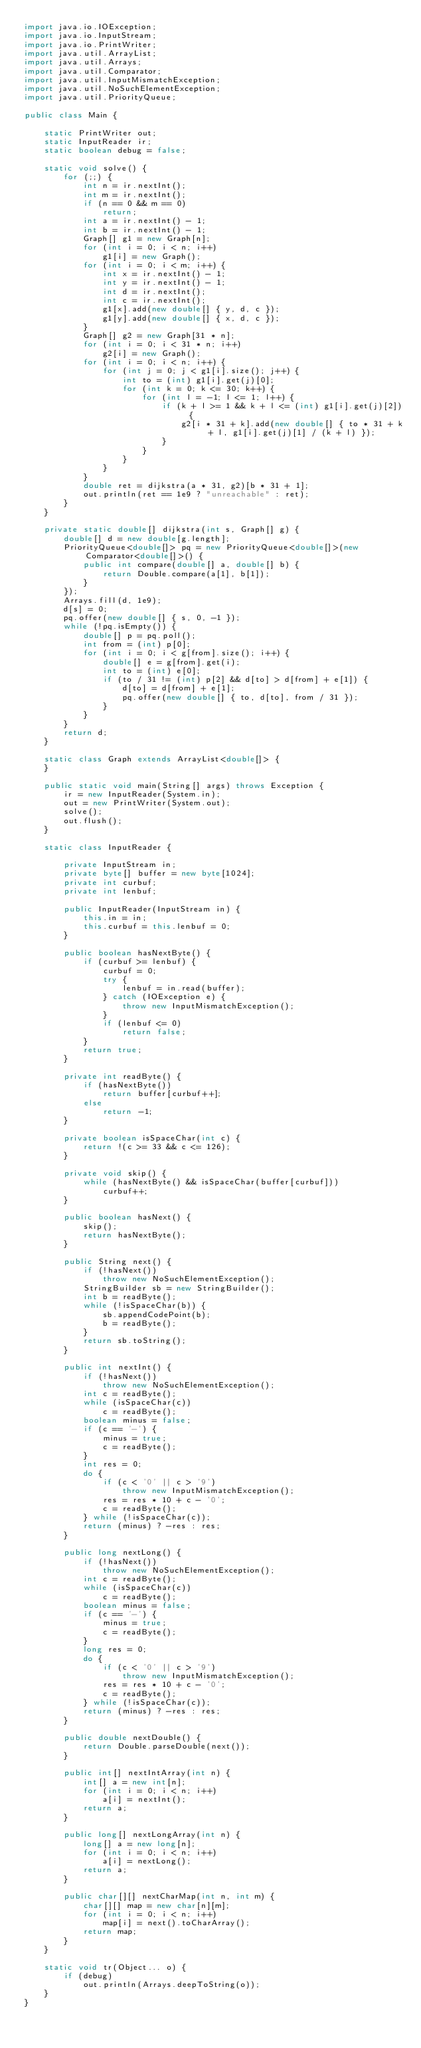<code> <loc_0><loc_0><loc_500><loc_500><_Java_>import java.io.IOException;
import java.io.InputStream;
import java.io.PrintWriter;
import java.util.ArrayList;
import java.util.Arrays;
import java.util.Comparator;
import java.util.InputMismatchException;
import java.util.NoSuchElementException;
import java.util.PriorityQueue;

public class Main {

	static PrintWriter out;
	static InputReader ir;
	static boolean debug = false;

	static void solve() {
		for (;;) {
			int n = ir.nextInt();
			int m = ir.nextInt();
			if (n == 0 && m == 0)
				return;
			int a = ir.nextInt() - 1;
			int b = ir.nextInt() - 1;
			Graph[] g1 = new Graph[n];
			for (int i = 0; i < n; i++)
				g1[i] = new Graph();
			for (int i = 0; i < m; i++) {
				int x = ir.nextInt() - 1;
				int y = ir.nextInt() - 1;
				int d = ir.nextInt();
				int c = ir.nextInt();
				g1[x].add(new double[] { y, d, c });
				g1[y].add(new double[] { x, d, c });
			}
			Graph[] g2 = new Graph[31 * n];
			for (int i = 0; i < 31 * n; i++)
				g2[i] = new Graph();
			for (int i = 0; i < n; i++) {
				for (int j = 0; j < g1[i].size(); j++) {
					int to = (int) g1[i].get(j)[0];
					for (int k = 0; k <= 30; k++) {
						for (int l = -1; l <= 1; l++) {
							if (k + l >= 1 && k + l <= (int) g1[i].get(j)[2]) {
								g2[i * 31 + k].add(new double[] { to * 31 + k + l, g1[i].get(j)[1] / (k + l) });
							}
						}
					}
				}
			}
			double ret = dijkstra(a * 31, g2)[b * 31 + 1];
			out.println(ret == 1e9 ? "unreachable" : ret);
		}
	}

	private static double[] dijkstra(int s, Graph[] g) {
		double[] d = new double[g.length];
		PriorityQueue<double[]> pq = new PriorityQueue<double[]>(new Comparator<double[]>() {
			public int compare(double[] a, double[] b) {
				return Double.compare(a[1], b[1]);
			}
		});
		Arrays.fill(d, 1e9);
		d[s] = 0;
		pq.offer(new double[] { s, 0, -1 });
		while (!pq.isEmpty()) {
			double[] p = pq.poll();
			int from = (int) p[0];
			for (int i = 0; i < g[from].size(); i++) {
				double[] e = g[from].get(i);
				int to = (int) e[0];
				if (to / 31 != (int) p[2] && d[to] > d[from] + e[1]) {
					d[to] = d[from] + e[1];
					pq.offer(new double[] { to, d[to], from / 31 });
				}
			}
		}
		return d;
	}

	static class Graph extends ArrayList<double[]> {
	}

	public static void main(String[] args) throws Exception {
		ir = new InputReader(System.in);
		out = new PrintWriter(System.out);
		solve();
		out.flush();
	}

	static class InputReader {

		private InputStream in;
		private byte[] buffer = new byte[1024];
		private int curbuf;
		private int lenbuf;

		public InputReader(InputStream in) {
			this.in = in;
			this.curbuf = this.lenbuf = 0;
		}

		public boolean hasNextByte() {
			if (curbuf >= lenbuf) {
				curbuf = 0;
				try {
					lenbuf = in.read(buffer);
				} catch (IOException e) {
					throw new InputMismatchException();
				}
				if (lenbuf <= 0)
					return false;
			}
			return true;
		}

		private int readByte() {
			if (hasNextByte())
				return buffer[curbuf++];
			else
				return -1;
		}

		private boolean isSpaceChar(int c) {
			return !(c >= 33 && c <= 126);
		}

		private void skip() {
			while (hasNextByte() && isSpaceChar(buffer[curbuf]))
				curbuf++;
		}

		public boolean hasNext() {
			skip();
			return hasNextByte();
		}

		public String next() {
			if (!hasNext())
				throw new NoSuchElementException();
			StringBuilder sb = new StringBuilder();
			int b = readByte();
			while (!isSpaceChar(b)) {
				sb.appendCodePoint(b);
				b = readByte();
			}
			return sb.toString();
		}

		public int nextInt() {
			if (!hasNext())
				throw new NoSuchElementException();
			int c = readByte();
			while (isSpaceChar(c))
				c = readByte();
			boolean minus = false;
			if (c == '-') {
				minus = true;
				c = readByte();
			}
			int res = 0;
			do {
				if (c < '0' || c > '9')
					throw new InputMismatchException();
				res = res * 10 + c - '0';
				c = readByte();
			} while (!isSpaceChar(c));
			return (minus) ? -res : res;
		}

		public long nextLong() {
			if (!hasNext())
				throw new NoSuchElementException();
			int c = readByte();
			while (isSpaceChar(c))
				c = readByte();
			boolean minus = false;
			if (c == '-') {
				minus = true;
				c = readByte();
			}
			long res = 0;
			do {
				if (c < '0' || c > '9')
					throw new InputMismatchException();
				res = res * 10 + c - '0';
				c = readByte();
			} while (!isSpaceChar(c));
			return (minus) ? -res : res;
		}

		public double nextDouble() {
			return Double.parseDouble(next());
		}

		public int[] nextIntArray(int n) {
			int[] a = new int[n];
			for (int i = 0; i < n; i++)
				a[i] = nextInt();
			return a;
		}

		public long[] nextLongArray(int n) {
			long[] a = new long[n];
			for (int i = 0; i < n; i++)
				a[i] = nextLong();
			return a;
		}

		public char[][] nextCharMap(int n, int m) {
			char[][] map = new char[n][m];
			for (int i = 0; i < n; i++)
				map[i] = next().toCharArray();
			return map;
		}
	}

	static void tr(Object... o) {
		if (debug)
			out.println(Arrays.deepToString(o));
	}
}

</code> 